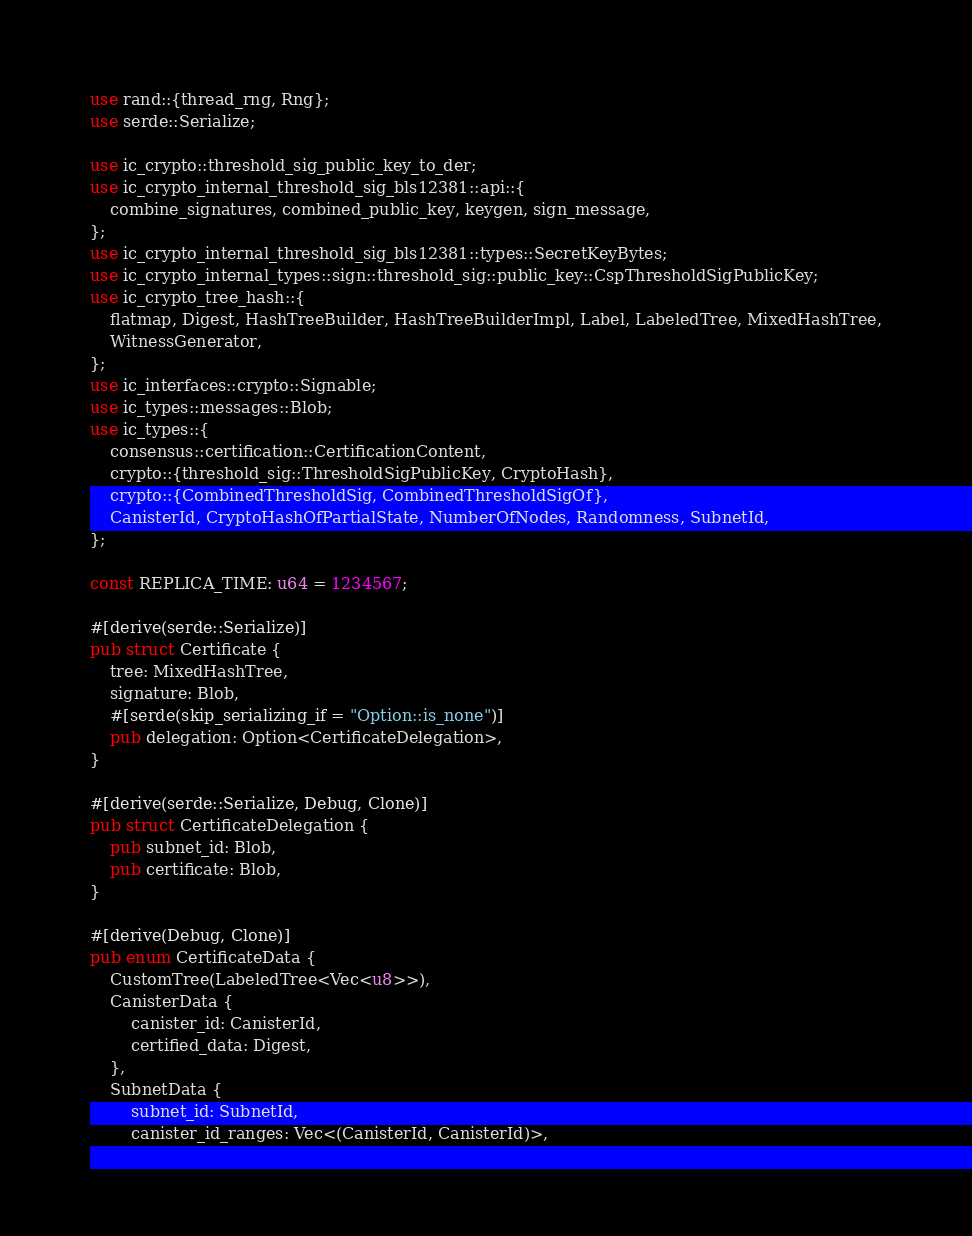<code> <loc_0><loc_0><loc_500><loc_500><_Rust_>use rand::{thread_rng, Rng};
use serde::Serialize;

use ic_crypto::threshold_sig_public_key_to_der;
use ic_crypto_internal_threshold_sig_bls12381::api::{
    combine_signatures, combined_public_key, keygen, sign_message,
};
use ic_crypto_internal_threshold_sig_bls12381::types::SecretKeyBytes;
use ic_crypto_internal_types::sign::threshold_sig::public_key::CspThresholdSigPublicKey;
use ic_crypto_tree_hash::{
    flatmap, Digest, HashTreeBuilder, HashTreeBuilderImpl, Label, LabeledTree, MixedHashTree,
    WitnessGenerator,
};
use ic_interfaces::crypto::Signable;
use ic_types::messages::Blob;
use ic_types::{
    consensus::certification::CertificationContent,
    crypto::{threshold_sig::ThresholdSigPublicKey, CryptoHash},
    crypto::{CombinedThresholdSig, CombinedThresholdSigOf},
    CanisterId, CryptoHashOfPartialState, NumberOfNodes, Randomness, SubnetId,
};

const REPLICA_TIME: u64 = 1234567;

#[derive(serde::Serialize)]
pub struct Certificate {
    tree: MixedHashTree,
    signature: Blob,
    #[serde(skip_serializing_if = "Option::is_none")]
    pub delegation: Option<CertificateDelegation>,
}

#[derive(serde::Serialize, Debug, Clone)]
pub struct CertificateDelegation {
    pub subnet_id: Blob,
    pub certificate: Blob,
}

#[derive(Debug, Clone)]
pub enum CertificateData {
    CustomTree(LabeledTree<Vec<u8>>),
    CanisterData {
        canister_id: CanisterId,
        certified_data: Digest,
    },
    SubnetData {
        subnet_id: SubnetId,
        canister_id_ranges: Vec<(CanisterId, CanisterId)>,</code> 